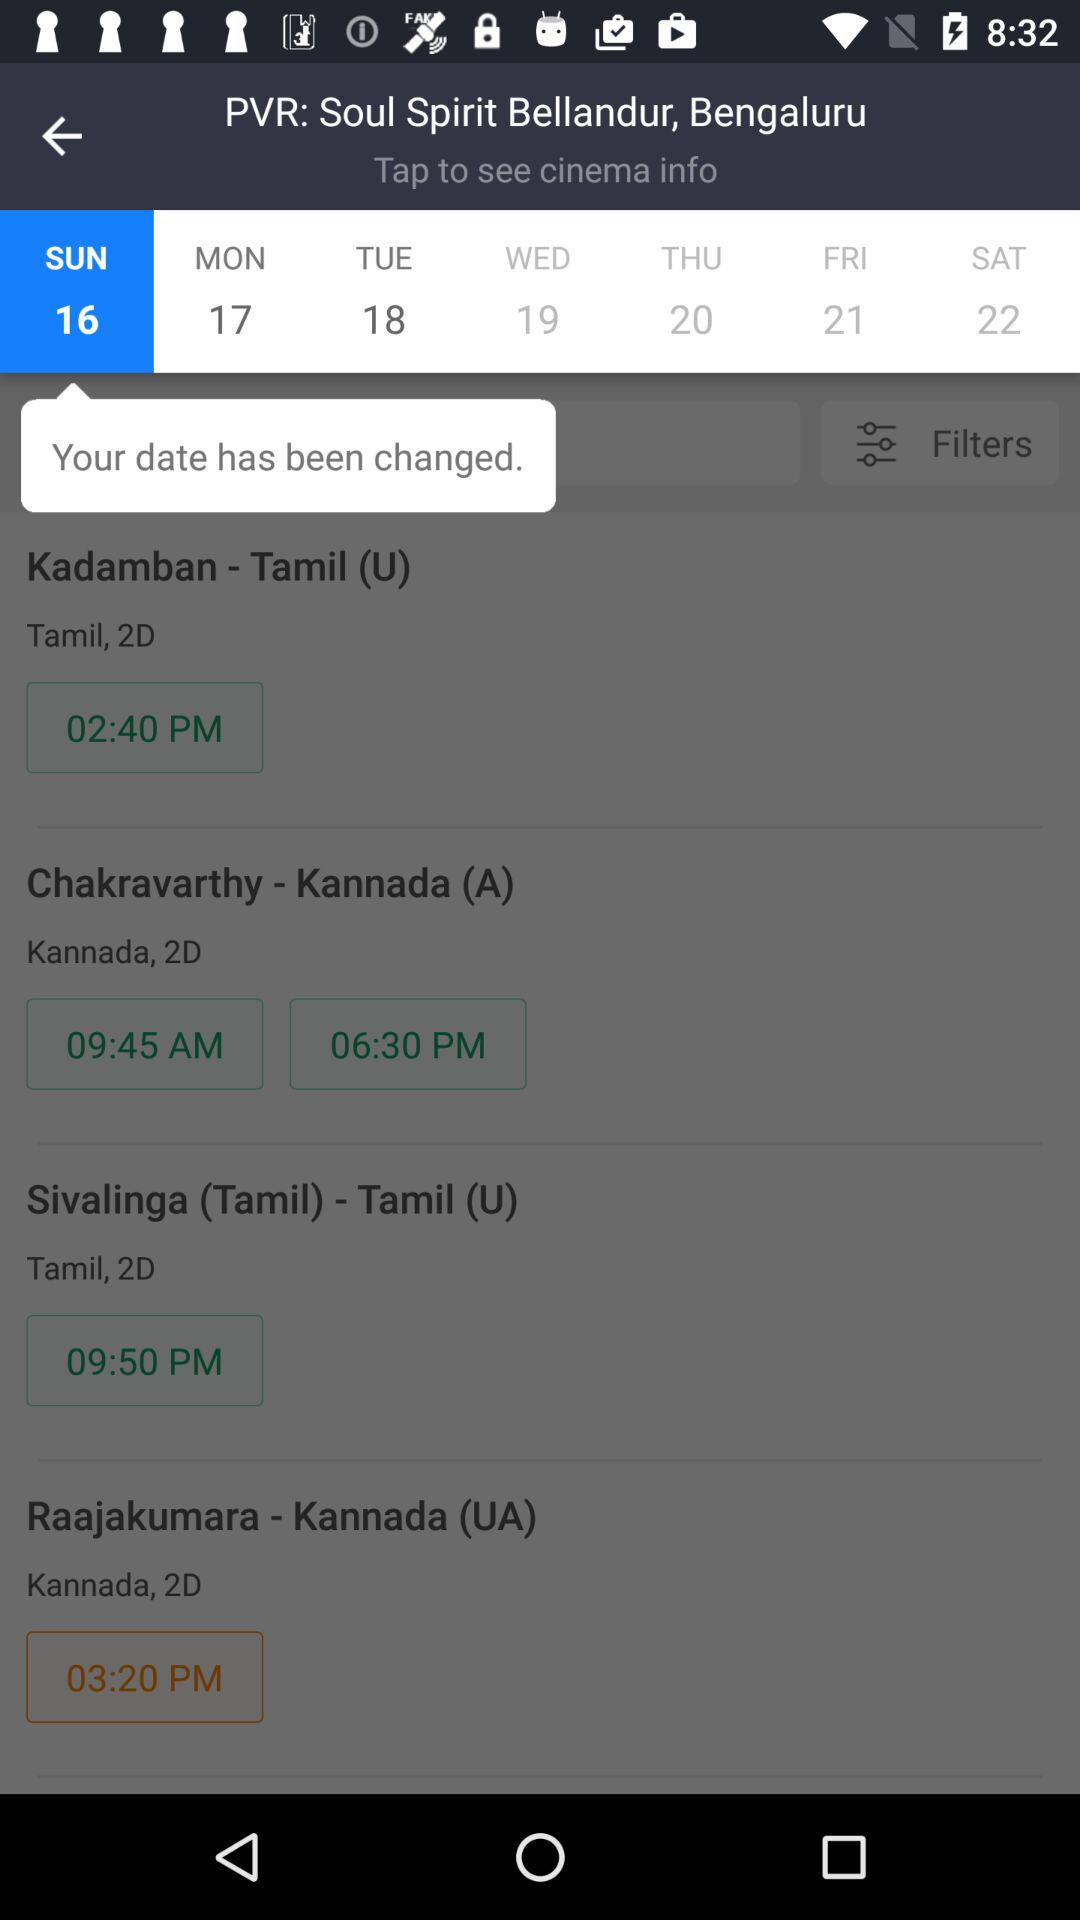What is the selected day? The selected day is Sunday. 